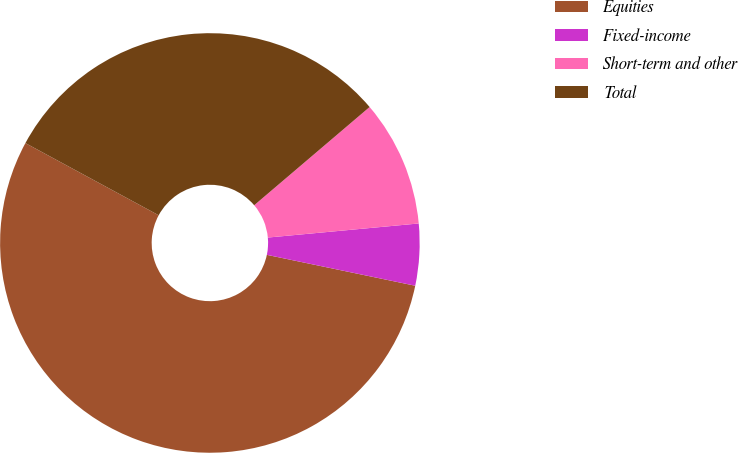Convert chart to OTSL. <chart><loc_0><loc_0><loc_500><loc_500><pie_chart><fcel>Equities<fcel>Fixed-income<fcel>Short-term and other<fcel>Total<nl><fcel>54.63%<fcel>4.75%<fcel>9.74%<fcel>30.88%<nl></chart> 